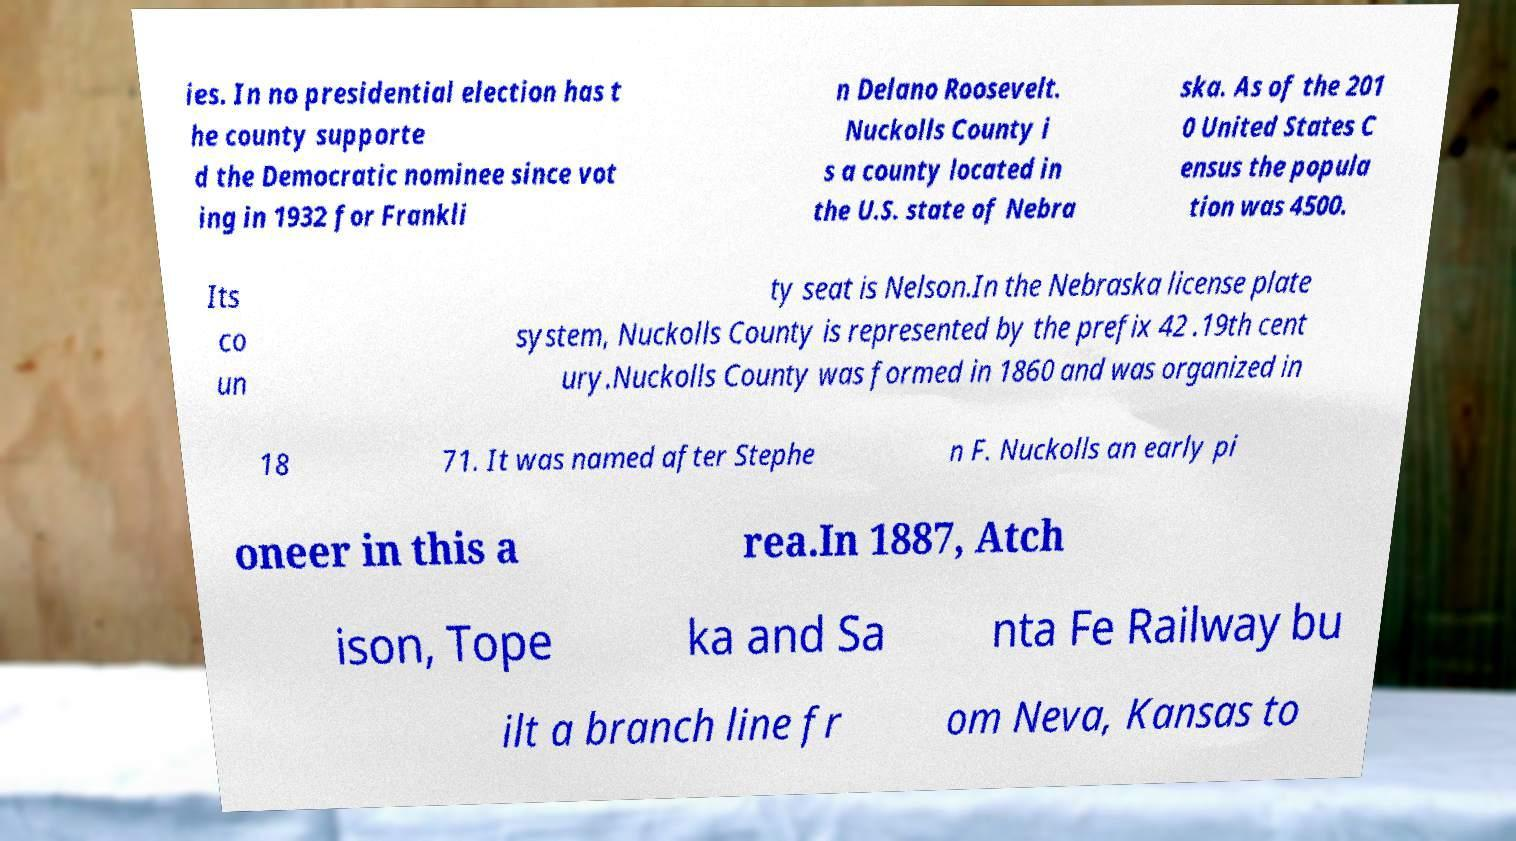What messages or text are displayed in this image? I need them in a readable, typed format. ies. In no presidential election has t he county supporte d the Democratic nominee since vot ing in 1932 for Frankli n Delano Roosevelt. Nuckolls County i s a county located in the U.S. state of Nebra ska. As of the 201 0 United States C ensus the popula tion was 4500. Its co un ty seat is Nelson.In the Nebraska license plate system, Nuckolls County is represented by the prefix 42 .19th cent ury.Nuckolls County was formed in 1860 and was organized in 18 71. It was named after Stephe n F. Nuckolls an early pi oneer in this a rea.In 1887, Atch ison, Tope ka and Sa nta Fe Railway bu ilt a branch line fr om Neva, Kansas to 